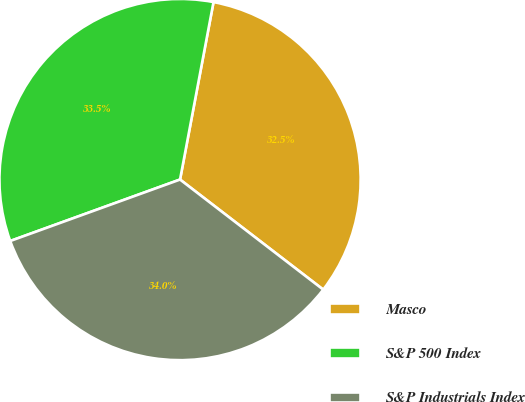Convert chart. <chart><loc_0><loc_0><loc_500><loc_500><pie_chart><fcel>Masco<fcel>S&P 500 Index<fcel>S&P Industrials Index<nl><fcel>32.46%<fcel>33.49%<fcel>34.04%<nl></chart> 